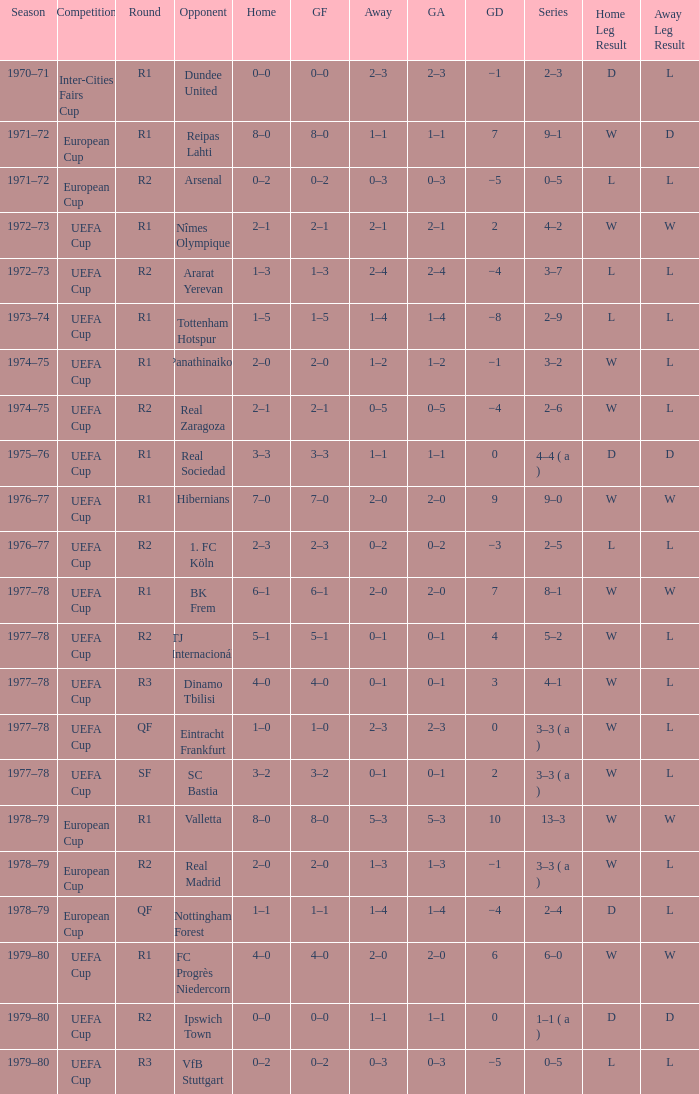Which Round has a Competition of uefa cup, and a Series of 5–2? R2. 